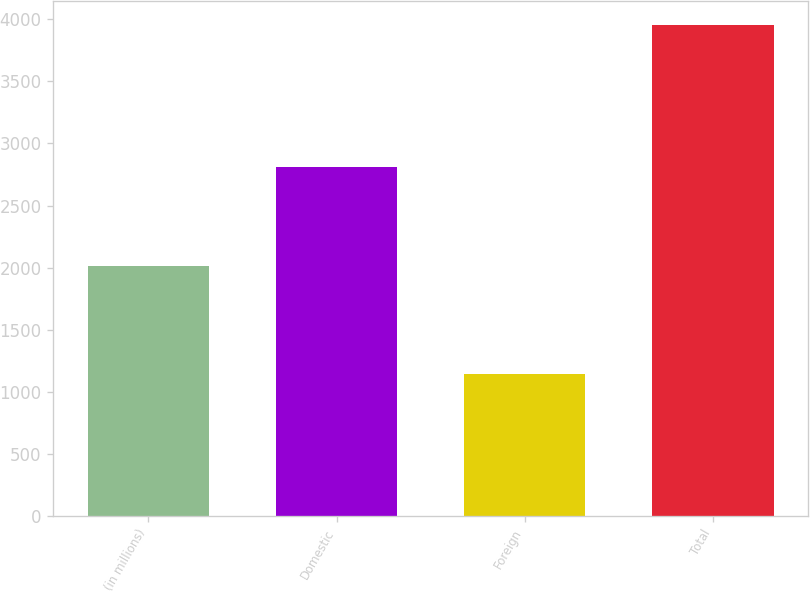Convert chart to OTSL. <chart><loc_0><loc_0><loc_500><loc_500><bar_chart><fcel>(in millions)<fcel>Domestic<fcel>Foreign<fcel>Total<nl><fcel>2013<fcel>2814<fcel>1140<fcel>3954<nl></chart> 